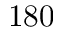<formula> <loc_0><loc_0><loc_500><loc_500>1 8 0</formula> 